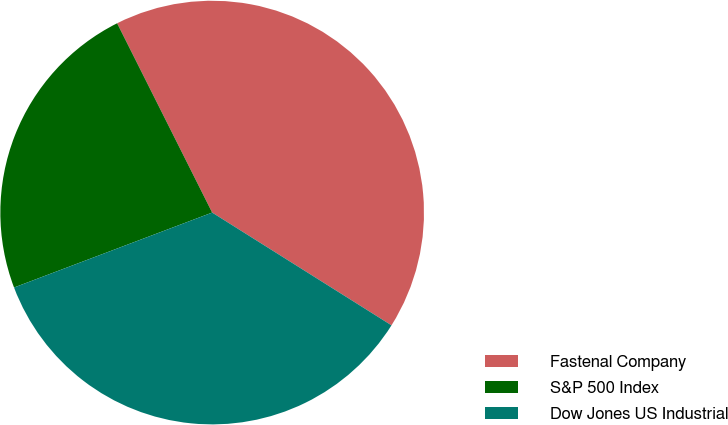Convert chart. <chart><loc_0><loc_0><loc_500><loc_500><pie_chart><fcel>Fastenal Company<fcel>S&P 500 Index<fcel>Dow Jones US Industrial<nl><fcel>41.34%<fcel>23.35%<fcel>35.31%<nl></chart> 